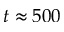Convert formula to latex. <formula><loc_0><loc_0><loc_500><loc_500>t \approx 5 0 0</formula> 